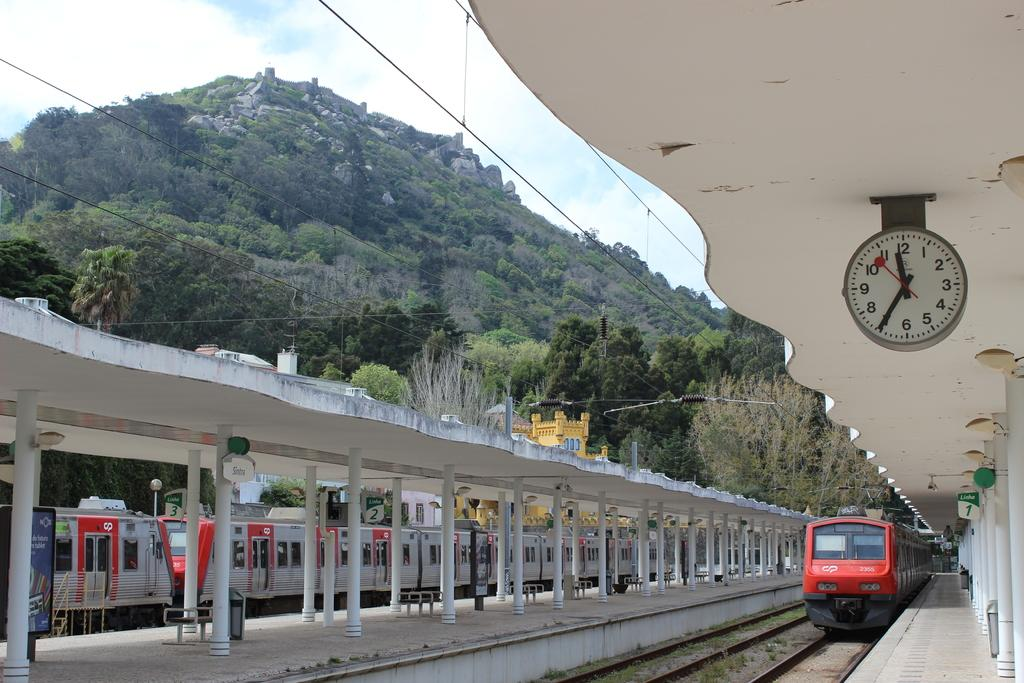<image>
Share a concise interpretation of the image provided. A red train in the distance with the numbers 2355 on the front 